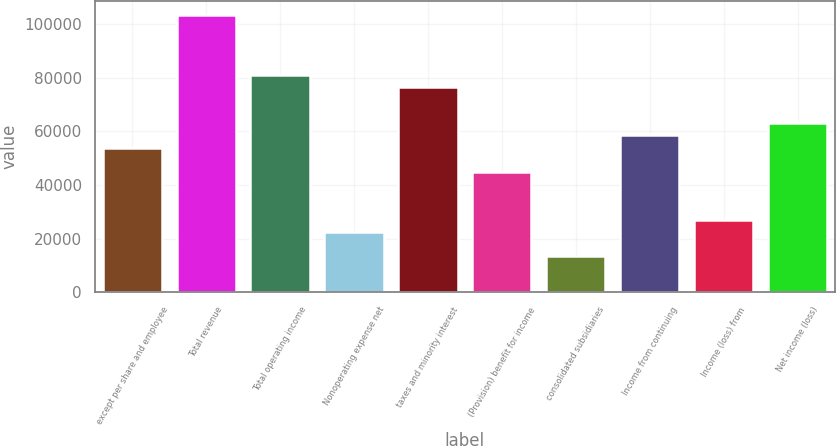Convert chart to OTSL. <chart><loc_0><loc_0><loc_500><loc_500><bar_chart><fcel>except per share and employee<fcel>Total revenue<fcel>Total operating income<fcel>Nonoperating expense net<fcel>taxes and minority interest<fcel>(Provision) benefit for income<fcel>consolidated subsidiaries<fcel>Income from continuing<fcel>Income (loss) from<fcel>Net income (loss)<nl><fcel>53999.9<fcel>103500<fcel>80999.8<fcel>22500.2<fcel>76499.8<fcel>45000<fcel>13500.2<fcel>58499.9<fcel>27000.1<fcel>62999.9<nl></chart> 